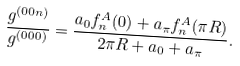Convert formula to latex. <formula><loc_0><loc_0><loc_500><loc_500>\frac { g ^ { ( 0 0 n ) } } { g ^ { ( 0 0 0 ) } } = \frac { a _ { 0 } f _ { n } ^ { A } ( 0 ) + a _ { \pi } f _ { n } ^ { A } ( \pi R ) } { 2 \pi R + a _ { 0 } + a _ { \pi } } .</formula> 